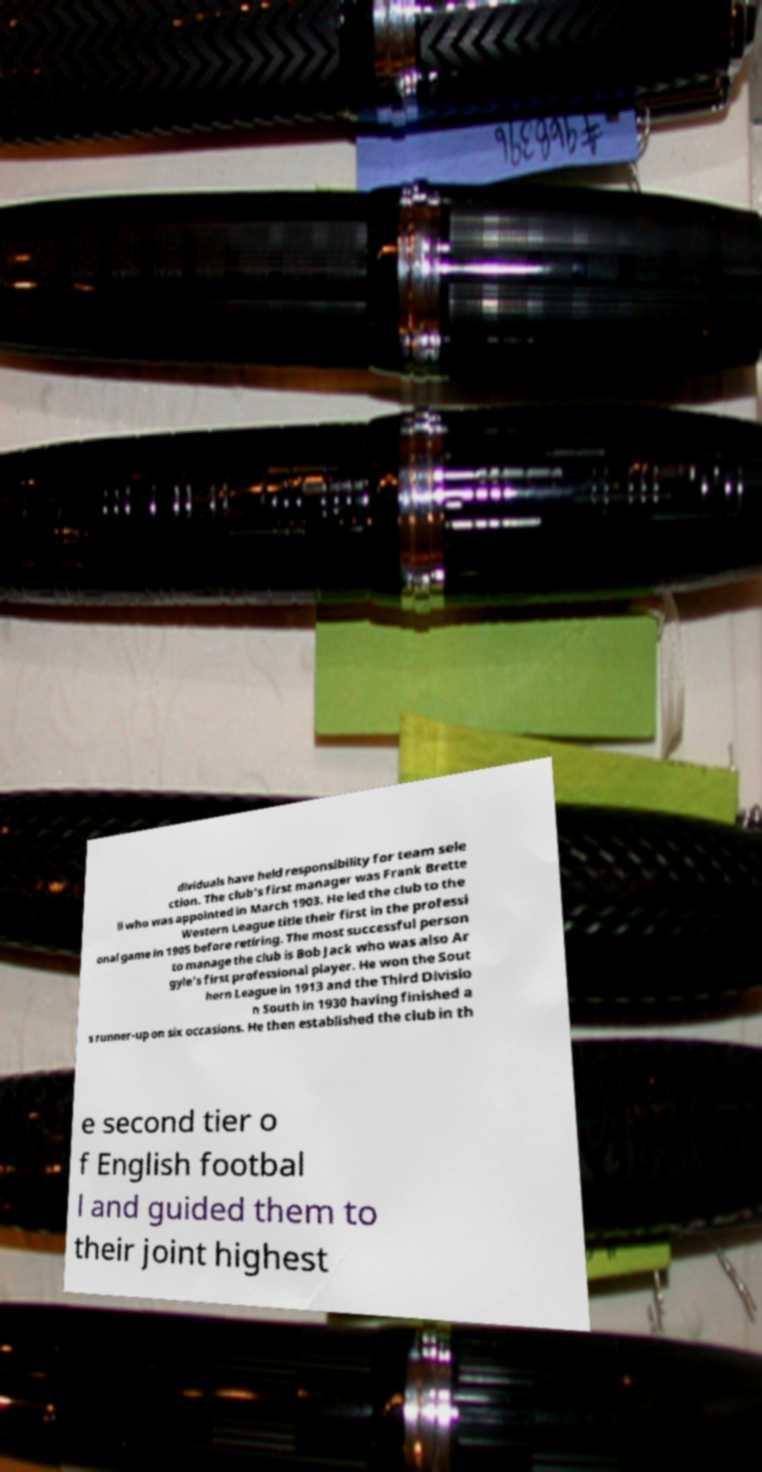There's text embedded in this image that I need extracted. Can you transcribe it verbatim? dividuals have held responsibility for team sele ction. The club's first manager was Frank Brette ll who was appointed in March 1903. He led the club to the Western League title their first in the professi onal game in 1905 before retiring. The most successful person to manage the club is Bob Jack who was also Ar gyle's first professional player. He won the Sout hern League in 1913 and the Third Divisio n South in 1930 having finished a s runner-up on six occasions. He then established the club in th e second tier o f English footbal l and guided them to their joint highest 